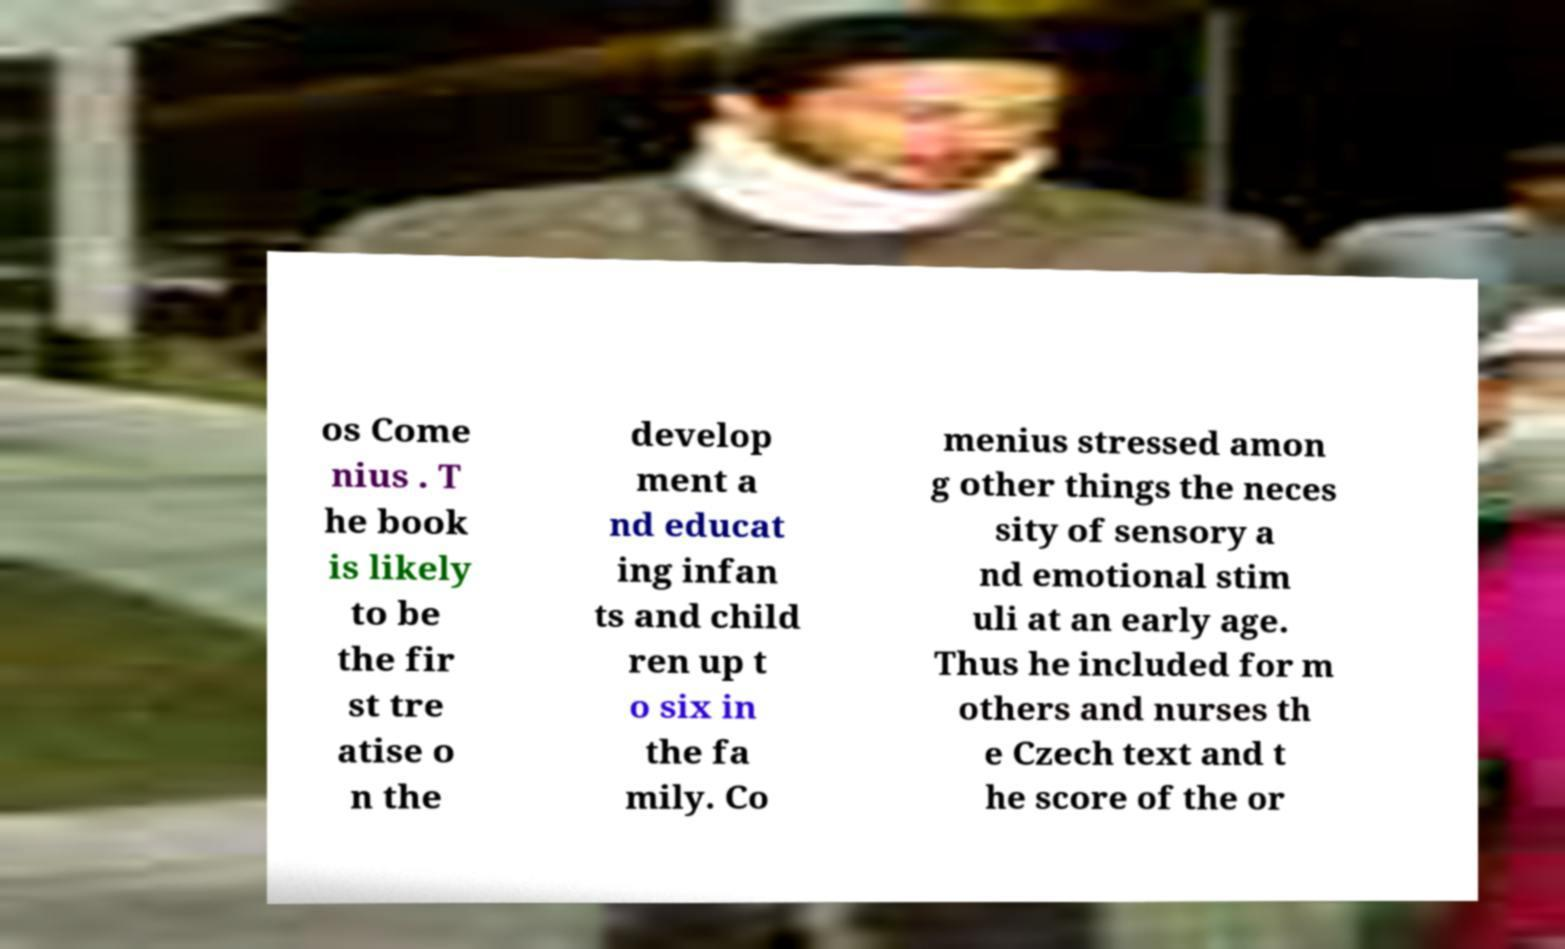Can you read and provide the text displayed in the image?This photo seems to have some interesting text. Can you extract and type it out for me? os Come nius . T he book is likely to be the fir st tre atise o n the develop ment a nd educat ing infan ts and child ren up t o six in the fa mily. Co menius stressed amon g other things the neces sity of sensory a nd emotional stim uli at an early age. Thus he included for m others and nurses th e Czech text and t he score of the or 